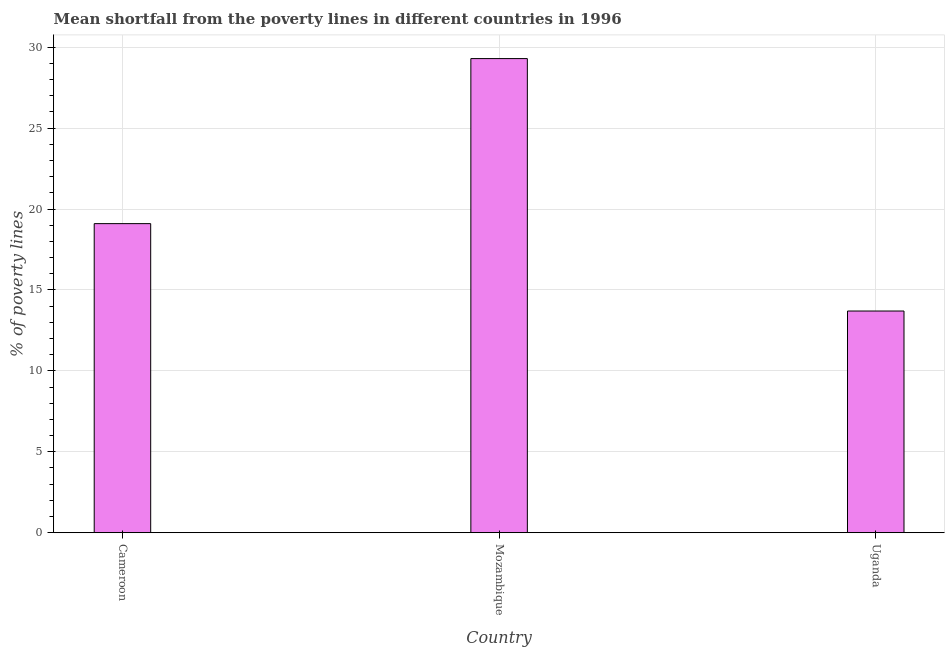Does the graph contain any zero values?
Your answer should be very brief. No. What is the title of the graph?
Keep it short and to the point. Mean shortfall from the poverty lines in different countries in 1996. What is the label or title of the Y-axis?
Provide a succinct answer. % of poverty lines. What is the poverty gap at national poverty lines in Mozambique?
Ensure brevity in your answer.  29.3. Across all countries, what is the maximum poverty gap at national poverty lines?
Your response must be concise. 29.3. Across all countries, what is the minimum poverty gap at national poverty lines?
Your response must be concise. 13.7. In which country was the poverty gap at national poverty lines maximum?
Provide a short and direct response. Mozambique. In which country was the poverty gap at national poverty lines minimum?
Offer a terse response. Uganda. What is the sum of the poverty gap at national poverty lines?
Your answer should be very brief. 62.1. What is the difference between the poverty gap at national poverty lines in Mozambique and Uganda?
Your answer should be compact. 15.6. What is the average poverty gap at national poverty lines per country?
Your answer should be compact. 20.7. What is the median poverty gap at national poverty lines?
Provide a short and direct response. 19.1. In how many countries, is the poverty gap at national poverty lines greater than 21 %?
Give a very brief answer. 1. What is the ratio of the poverty gap at national poverty lines in Mozambique to that in Uganda?
Your answer should be compact. 2.14. How many bars are there?
Your answer should be compact. 3. Are all the bars in the graph horizontal?
Offer a very short reply. No. How many countries are there in the graph?
Provide a succinct answer. 3. What is the difference between two consecutive major ticks on the Y-axis?
Provide a succinct answer. 5. Are the values on the major ticks of Y-axis written in scientific E-notation?
Your response must be concise. No. What is the % of poverty lines of Mozambique?
Offer a terse response. 29.3. What is the % of poverty lines in Uganda?
Your answer should be compact. 13.7. What is the ratio of the % of poverty lines in Cameroon to that in Mozambique?
Your answer should be very brief. 0.65. What is the ratio of the % of poverty lines in Cameroon to that in Uganda?
Ensure brevity in your answer.  1.39. What is the ratio of the % of poverty lines in Mozambique to that in Uganda?
Your response must be concise. 2.14. 